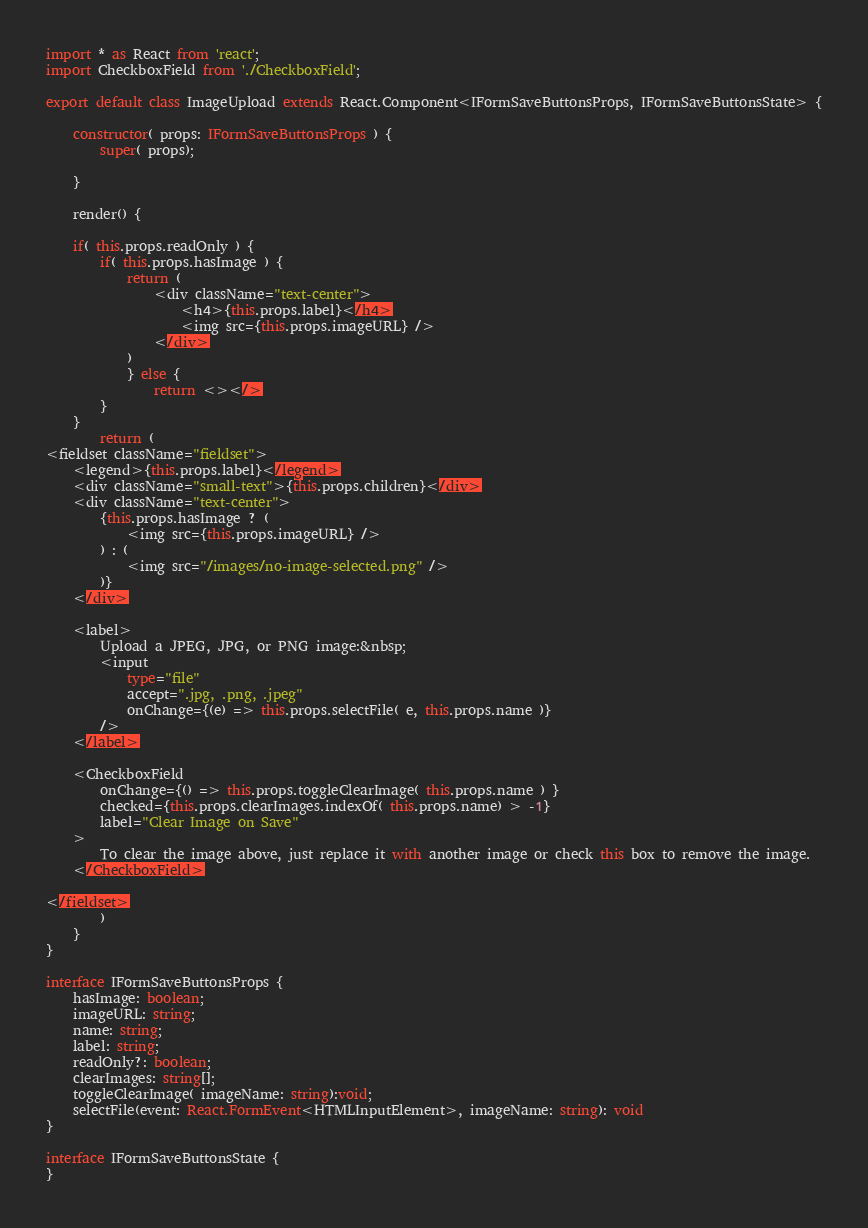<code> <loc_0><loc_0><loc_500><loc_500><_TypeScript_>import * as React from 'react';
import CheckboxField from './CheckboxField';

export default class ImageUpload extends React.Component<IFormSaveButtonsProps, IFormSaveButtonsState> {

    constructor( props: IFormSaveButtonsProps ) {
        super( props);

    }

    render() {

    if( this.props.readOnly ) {
        if( this.props.hasImage ) {
            return (
                <div className="text-center">
                    <h4>{this.props.label}</h4>
                    <img src={this.props.imageURL} />
                </div>
            )
            } else {
                return <></>
        }
    }
        return (
<fieldset className="fieldset">
    <legend>{this.props.label}</legend>
    <div className="small-text">{this.props.children}</div>
    <div className="text-center">
        {this.props.hasImage ? (
            <img src={this.props.imageURL} />
        ) : (
            <img src="/images/no-image-selected.png" />
        )}
    </div>

    <label>
        Upload a JPEG, JPG, or PNG image:&nbsp;
        <input
            type="file"
            accept=".jpg, .png, .jpeg"
            onChange={(e) => this.props.selectFile( e, this.props.name )}
        />
    </label>

    <CheckboxField
        onChange={() => this.props.toggleClearImage( this.props.name ) }
        checked={this.props.clearImages.indexOf( this.props.name) > -1}
        label="Clear Image on Save"
    >
        To clear the image above, just replace it with another image or check this box to remove the image.
    </CheckboxField>

</fieldset>
        )
    }
}

interface IFormSaveButtonsProps {
    hasImage: boolean;
    imageURL: string;
    name: string;
    label: string;
    readOnly?: boolean;
    clearImages: string[];
    toggleClearImage( imageName: string):void;
    selectFile(event: React.FormEvent<HTMLInputElement>, imageName: string): void
}

interface IFormSaveButtonsState {
}</code> 